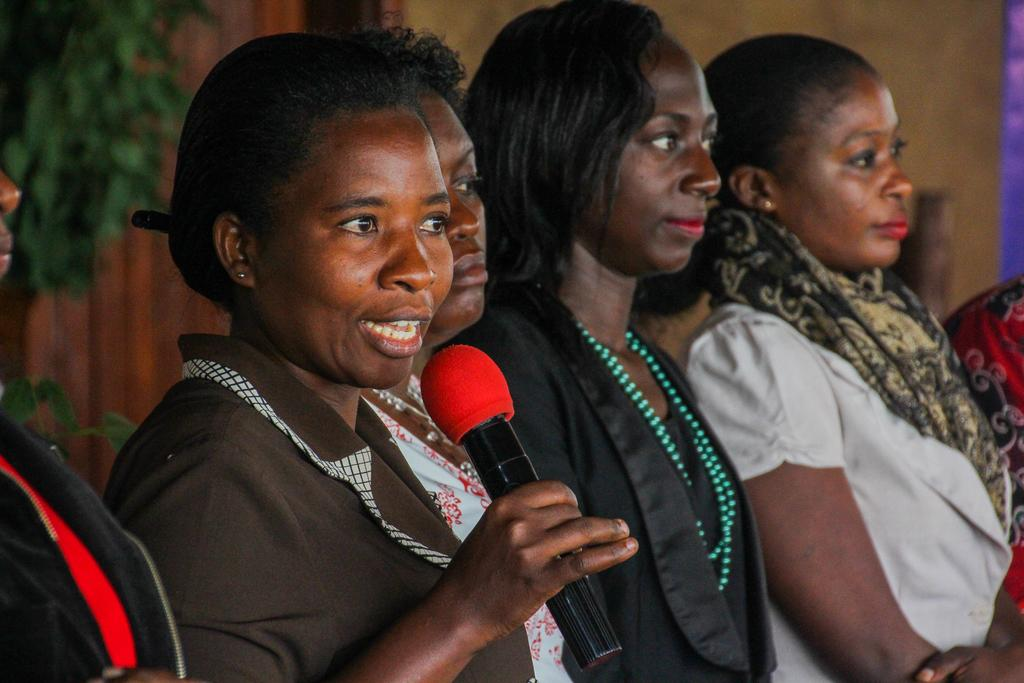How many people are in the image? There is a group of persons in the image. What is one person in the group holding? One person is holding a microphone in their hand. What type of leather is being used to make the tramp in the image? There is no tramp or leather present in the image. 